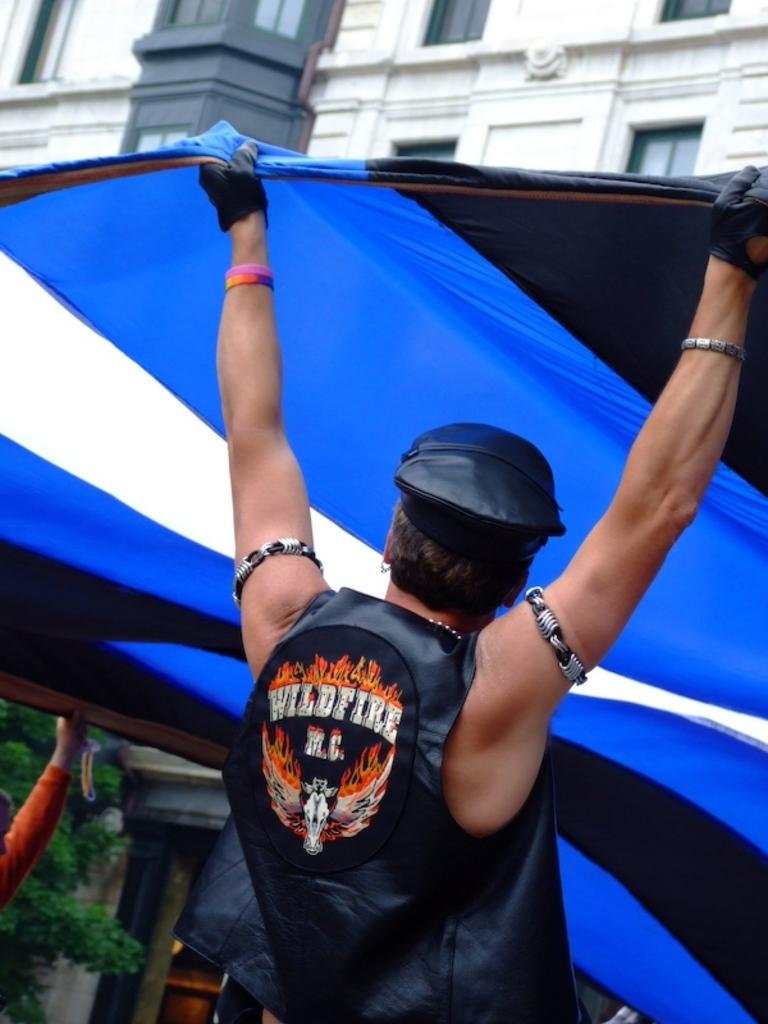What are the two people in the image doing? The two people are holding a tent in the image. Can you describe the clothing of one of the people? One person is wearing a cap, jacket, and gloves. What can be seen in the background of the image? There is a tree and a building with windows in the background of the image. What type of lunch is being prepared by the tree in the image? There is no lunch being prepared in the image, and the tree is not involved in any food preparation. 